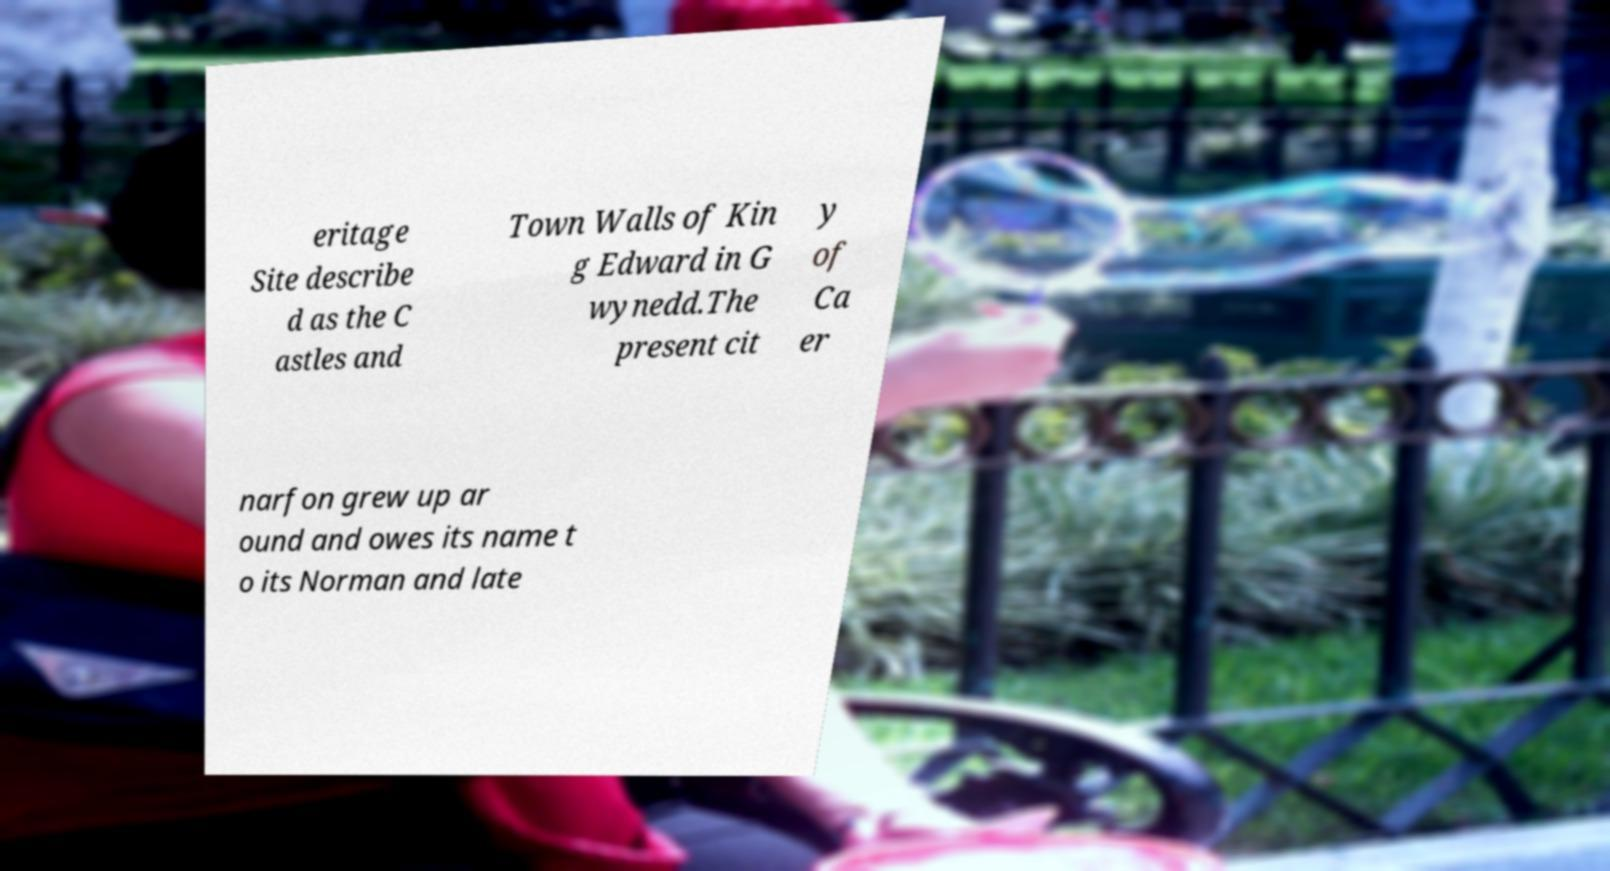Can you accurately transcribe the text from the provided image for me? eritage Site describe d as the C astles and Town Walls of Kin g Edward in G wynedd.The present cit y of Ca er narfon grew up ar ound and owes its name t o its Norman and late 